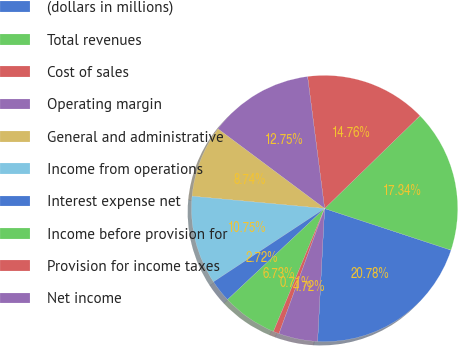<chart> <loc_0><loc_0><loc_500><loc_500><pie_chart><fcel>(dollars in millions)<fcel>Total revenues<fcel>Cost of sales<fcel>Operating margin<fcel>General and administrative<fcel>Income from operations<fcel>Interest expense net<fcel>Income before provision for<fcel>Provision for income taxes<fcel>Net income<nl><fcel>20.78%<fcel>17.34%<fcel>14.76%<fcel>12.75%<fcel>8.74%<fcel>10.75%<fcel>2.72%<fcel>6.73%<fcel>0.71%<fcel>4.72%<nl></chart> 